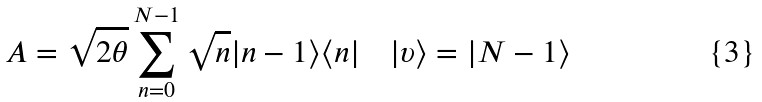<formula> <loc_0><loc_0><loc_500><loc_500>A = \sqrt { 2 \theta } \sum _ { n = 0 } ^ { N - 1 } \sqrt { n } | n - 1 \rangle \langle n | \quad | \upsilon \rangle = | N - 1 \rangle</formula> 